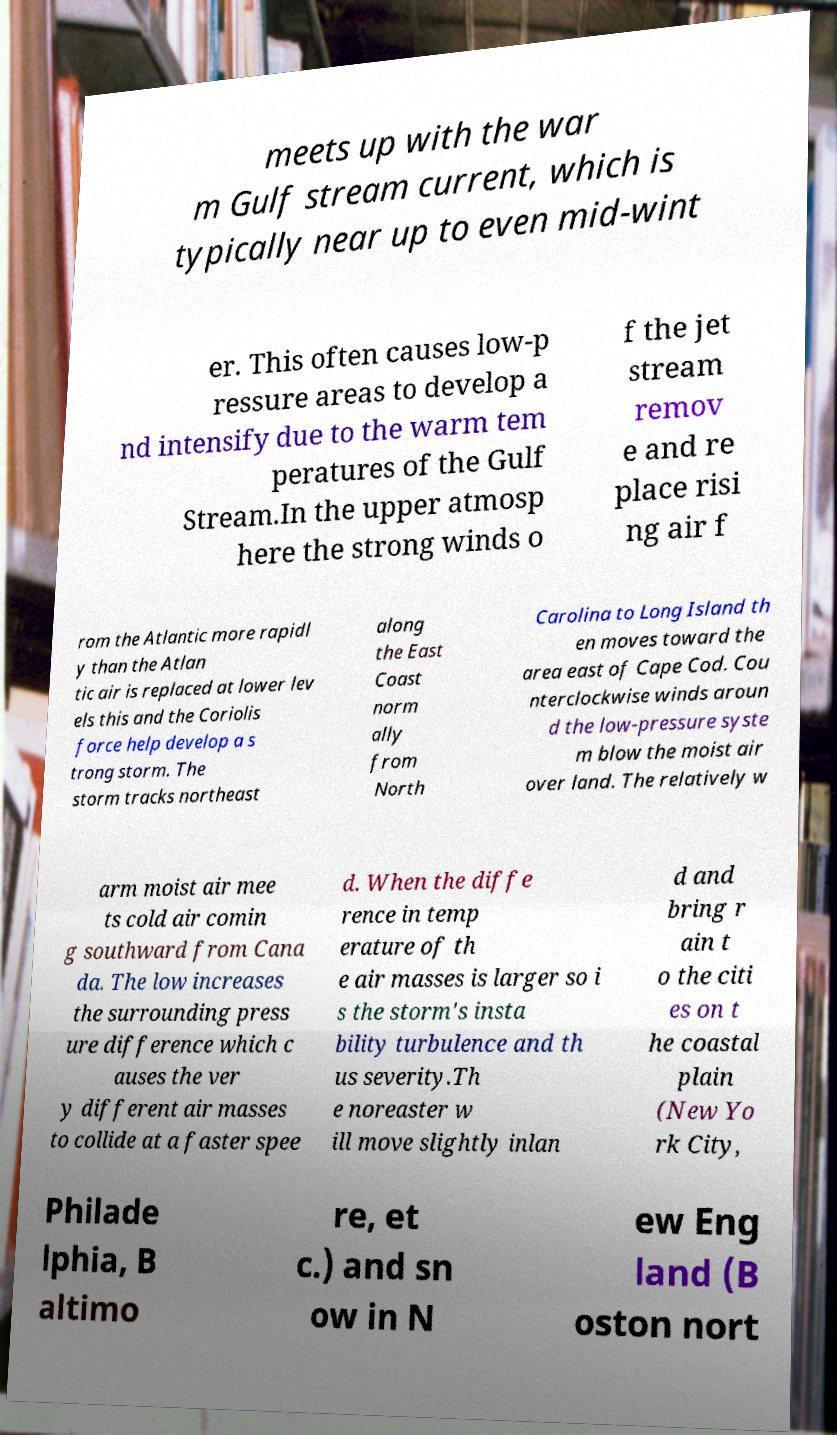What messages or text are displayed in this image? I need them in a readable, typed format. meets up with the war m Gulf stream current, which is typically near up to even mid-wint er. This often causes low-p ressure areas to develop a nd intensify due to the warm tem peratures of the Gulf Stream.In the upper atmosp here the strong winds o f the jet stream remov e and re place risi ng air f rom the Atlantic more rapidl y than the Atlan tic air is replaced at lower lev els this and the Coriolis force help develop a s trong storm. The storm tracks northeast along the East Coast norm ally from North Carolina to Long Island th en moves toward the area east of Cape Cod. Cou nterclockwise winds aroun d the low-pressure syste m blow the moist air over land. The relatively w arm moist air mee ts cold air comin g southward from Cana da. The low increases the surrounding press ure difference which c auses the ver y different air masses to collide at a faster spee d. When the diffe rence in temp erature of th e air masses is larger so i s the storm's insta bility turbulence and th us severity.Th e noreaster w ill move slightly inlan d and bring r ain t o the citi es on t he coastal plain (New Yo rk City, Philade lphia, B altimo re, et c.) and sn ow in N ew Eng land (B oston nort 